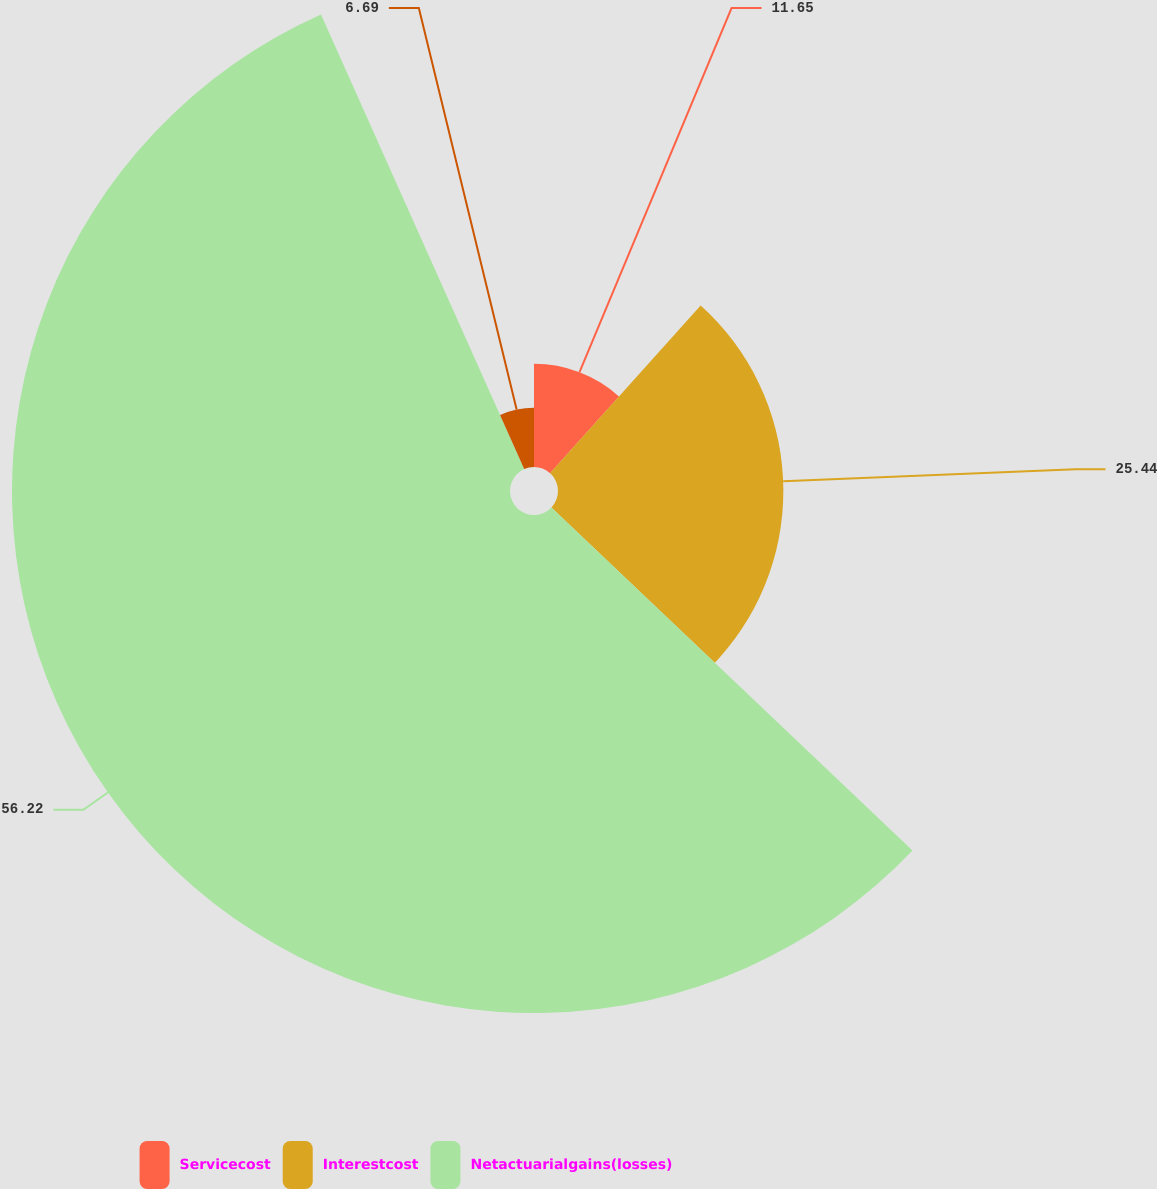<chart> <loc_0><loc_0><loc_500><loc_500><pie_chart><fcel>Servicecost<fcel>Interestcost<fcel>Netactuarialgains(losses)<fcel>Unnamed: 3<nl><fcel>11.65%<fcel>25.44%<fcel>56.22%<fcel>6.69%<nl></chart> 